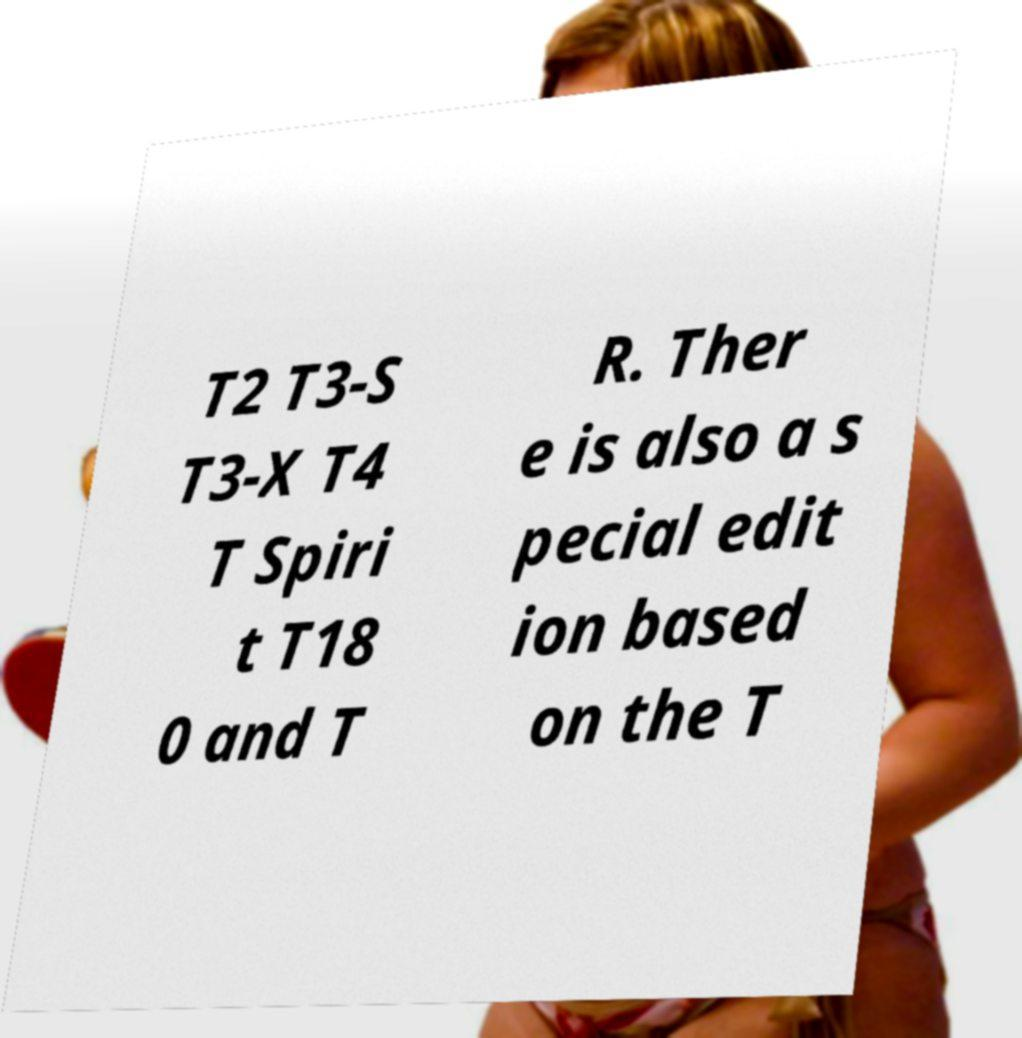Can you accurately transcribe the text from the provided image for me? T2 T3-S T3-X T4 T Spiri t T18 0 and T R. Ther e is also a s pecial edit ion based on the T 